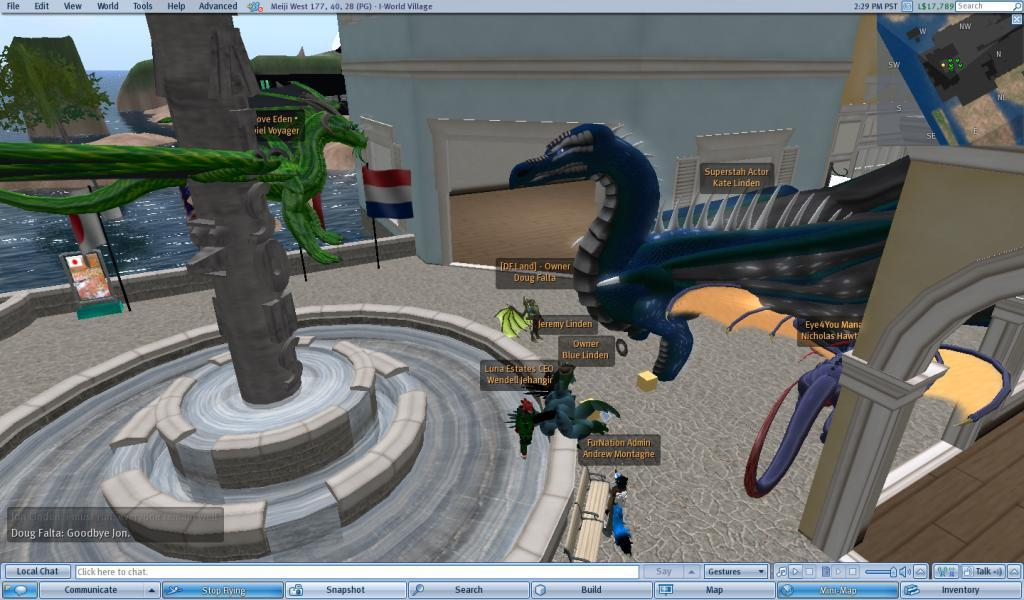What type of animation is being described in the transcript? The transcript describes an animation featuring a character named "Bob" who is trying to find a way to get to the top of a mountain. What is the main challenge that Bob faces in the animation? Bob faces the challenge of finding a way to get to the top of the mountain. Are there any other characters or elements in the animation? The transcript does not mention any other characters or elements in the animation. What is the setting or environment of the animation? The setting of the animation is a mountainous area. What type of vase can be seen on the mountain in the animation? There is no mention of a vase in the transcript, so it cannot be determined if one is present in the animation. 